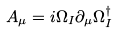<formula> <loc_0><loc_0><loc_500><loc_500>A _ { \mu } = i \Omega _ { I } \partial _ { \mu } \Omega _ { I } ^ { \dagger }</formula> 